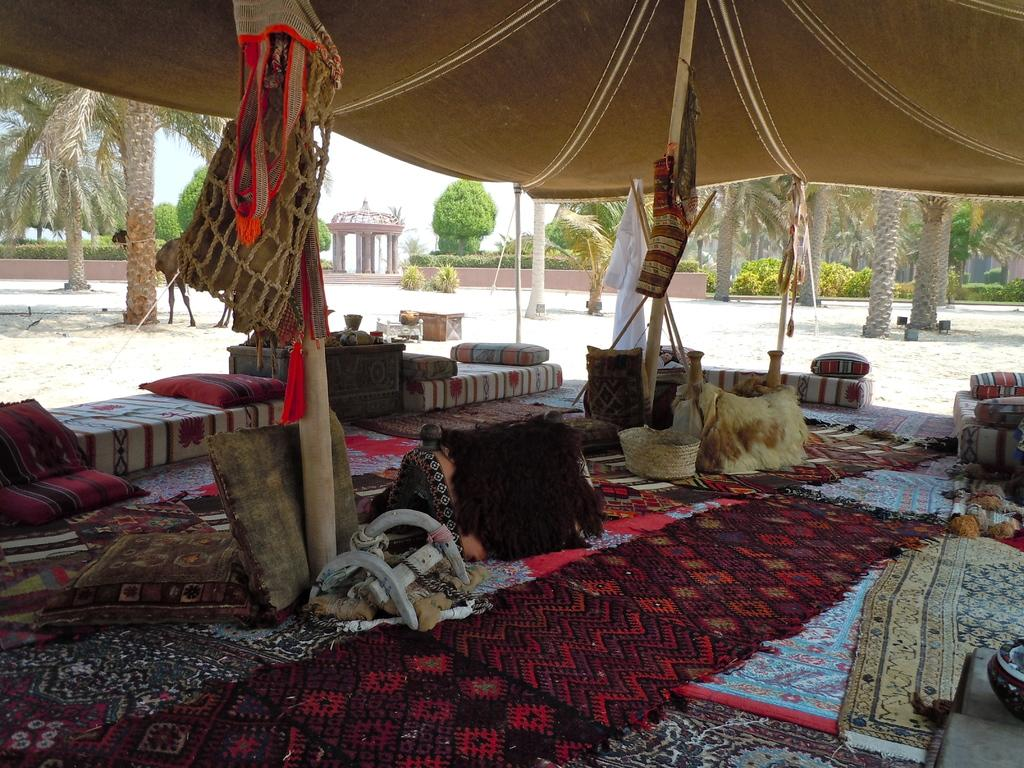What type of furniture can be seen in the image? There are pillows, carpets, and beds in the image. Where are these items located? These items are under a tent. What can be seen in the background of the image? There are trees in the background of the image. Can you tell me what color the bird's eye is in the image? There is no bird or eye present in the image. 